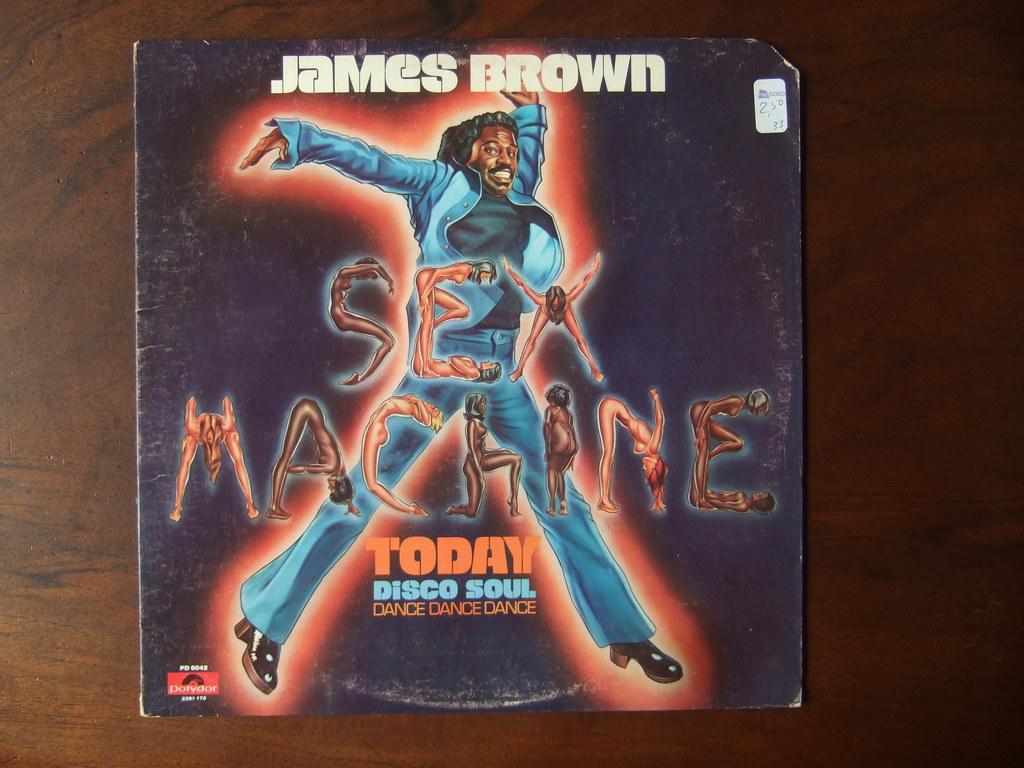Provide a one-sentence caption for the provided image. Album cover for James Brown's long awaited "Sex Machine". 